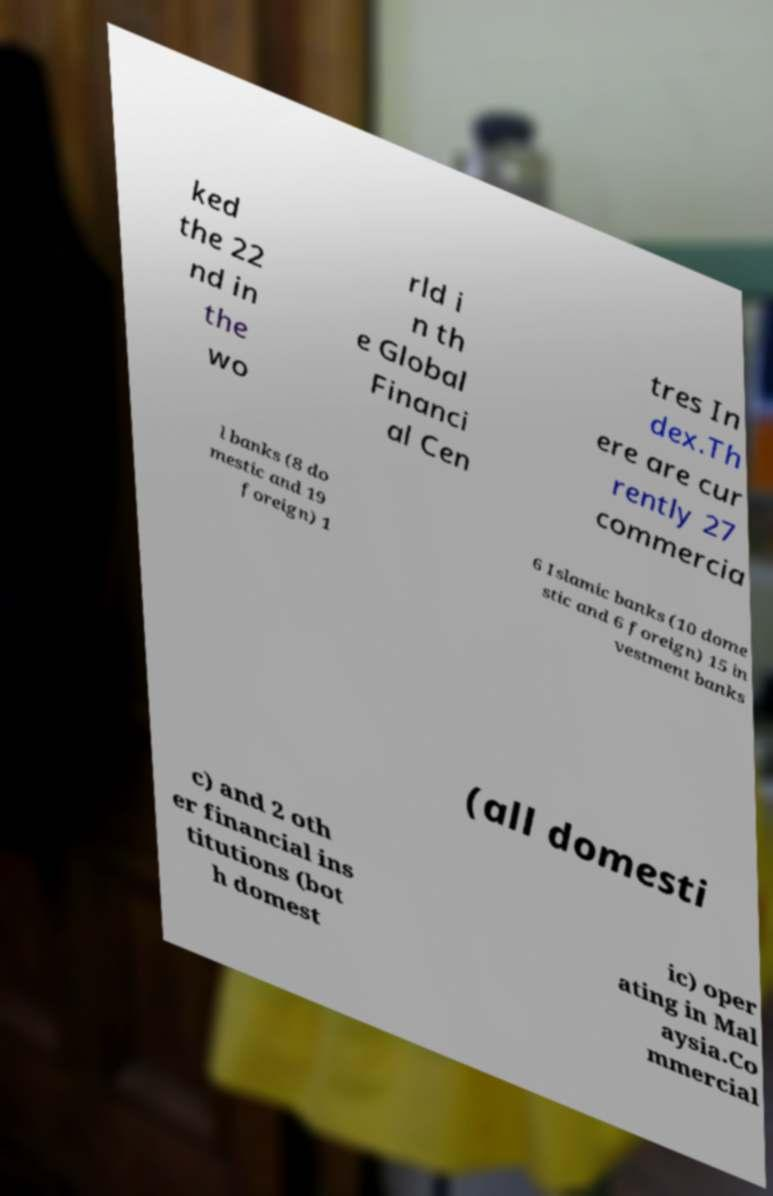Please identify and transcribe the text found in this image. ked the 22 nd in the wo rld i n th e Global Financi al Cen tres In dex.Th ere are cur rently 27 commercia l banks (8 do mestic and 19 foreign) 1 6 Islamic banks (10 dome stic and 6 foreign) 15 in vestment banks (all domesti c) and 2 oth er financial ins titutions (bot h domest ic) oper ating in Mal aysia.Co mmercial 